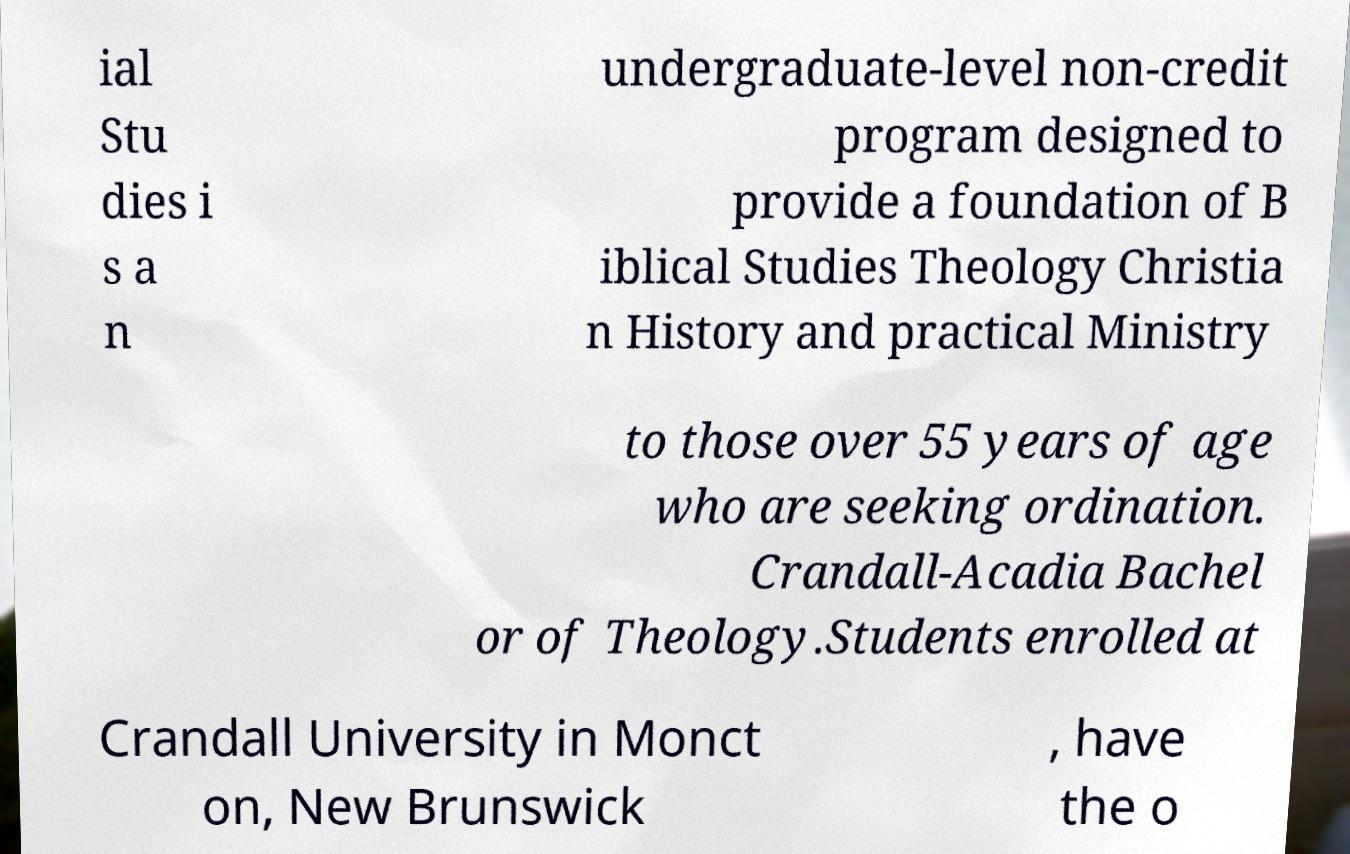Please identify and transcribe the text found in this image. ial Stu dies i s a n undergraduate-level non-credit program designed to provide a foundation of B iblical Studies Theology Christia n History and practical Ministry to those over 55 years of age who are seeking ordination. Crandall-Acadia Bachel or of Theology.Students enrolled at Crandall University in Monct on, New Brunswick , have the o 